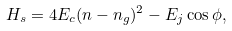<formula> <loc_0><loc_0><loc_500><loc_500>H _ { s } = 4 E _ { c } ( n - n _ { g } ) ^ { 2 } - E _ { j } \cos \phi ,</formula> 